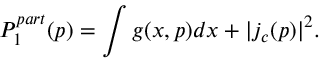<formula> <loc_0><loc_0><loc_500><loc_500>P _ { 1 } ^ { p a r t } ( p ) = \int g ( x , p ) d x + | j _ { c } ( p ) | ^ { 2 } .</formula> 